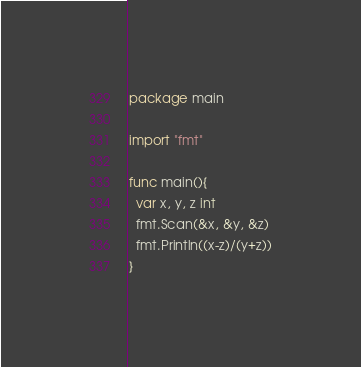<code> <loc_0><loc_0><loc_500><loc_500><_Go_>package main

import "fmt"

func main(){
  var x, y, z int
  fmt.Scan(&x, &y, &z)
  fmt.Println((x-z)/(y+z))
}
</code> 